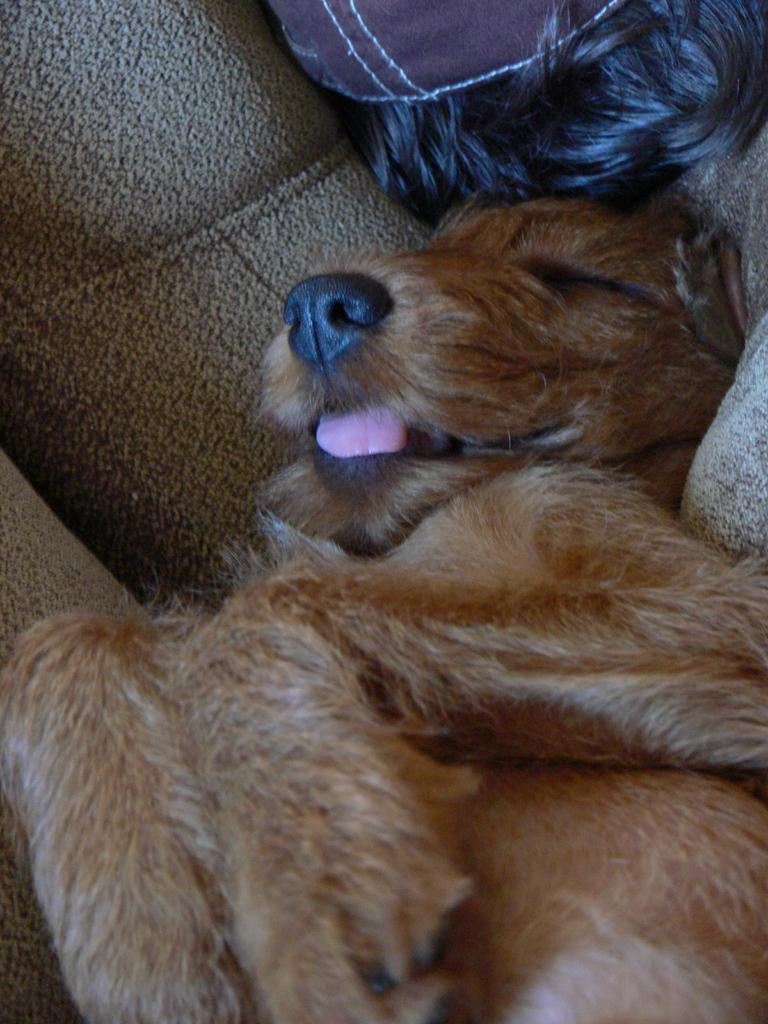What animal can be seen in the picture? There is a dog in the picture. What is the dog doing in the picture? The dog is sleeping on the sofa. What color is the dog in the picture? The dog is brown in color. What type of knife is being used to show the dog in the picture? There is no knife present in the image, and the dog is not being shown by any object. 